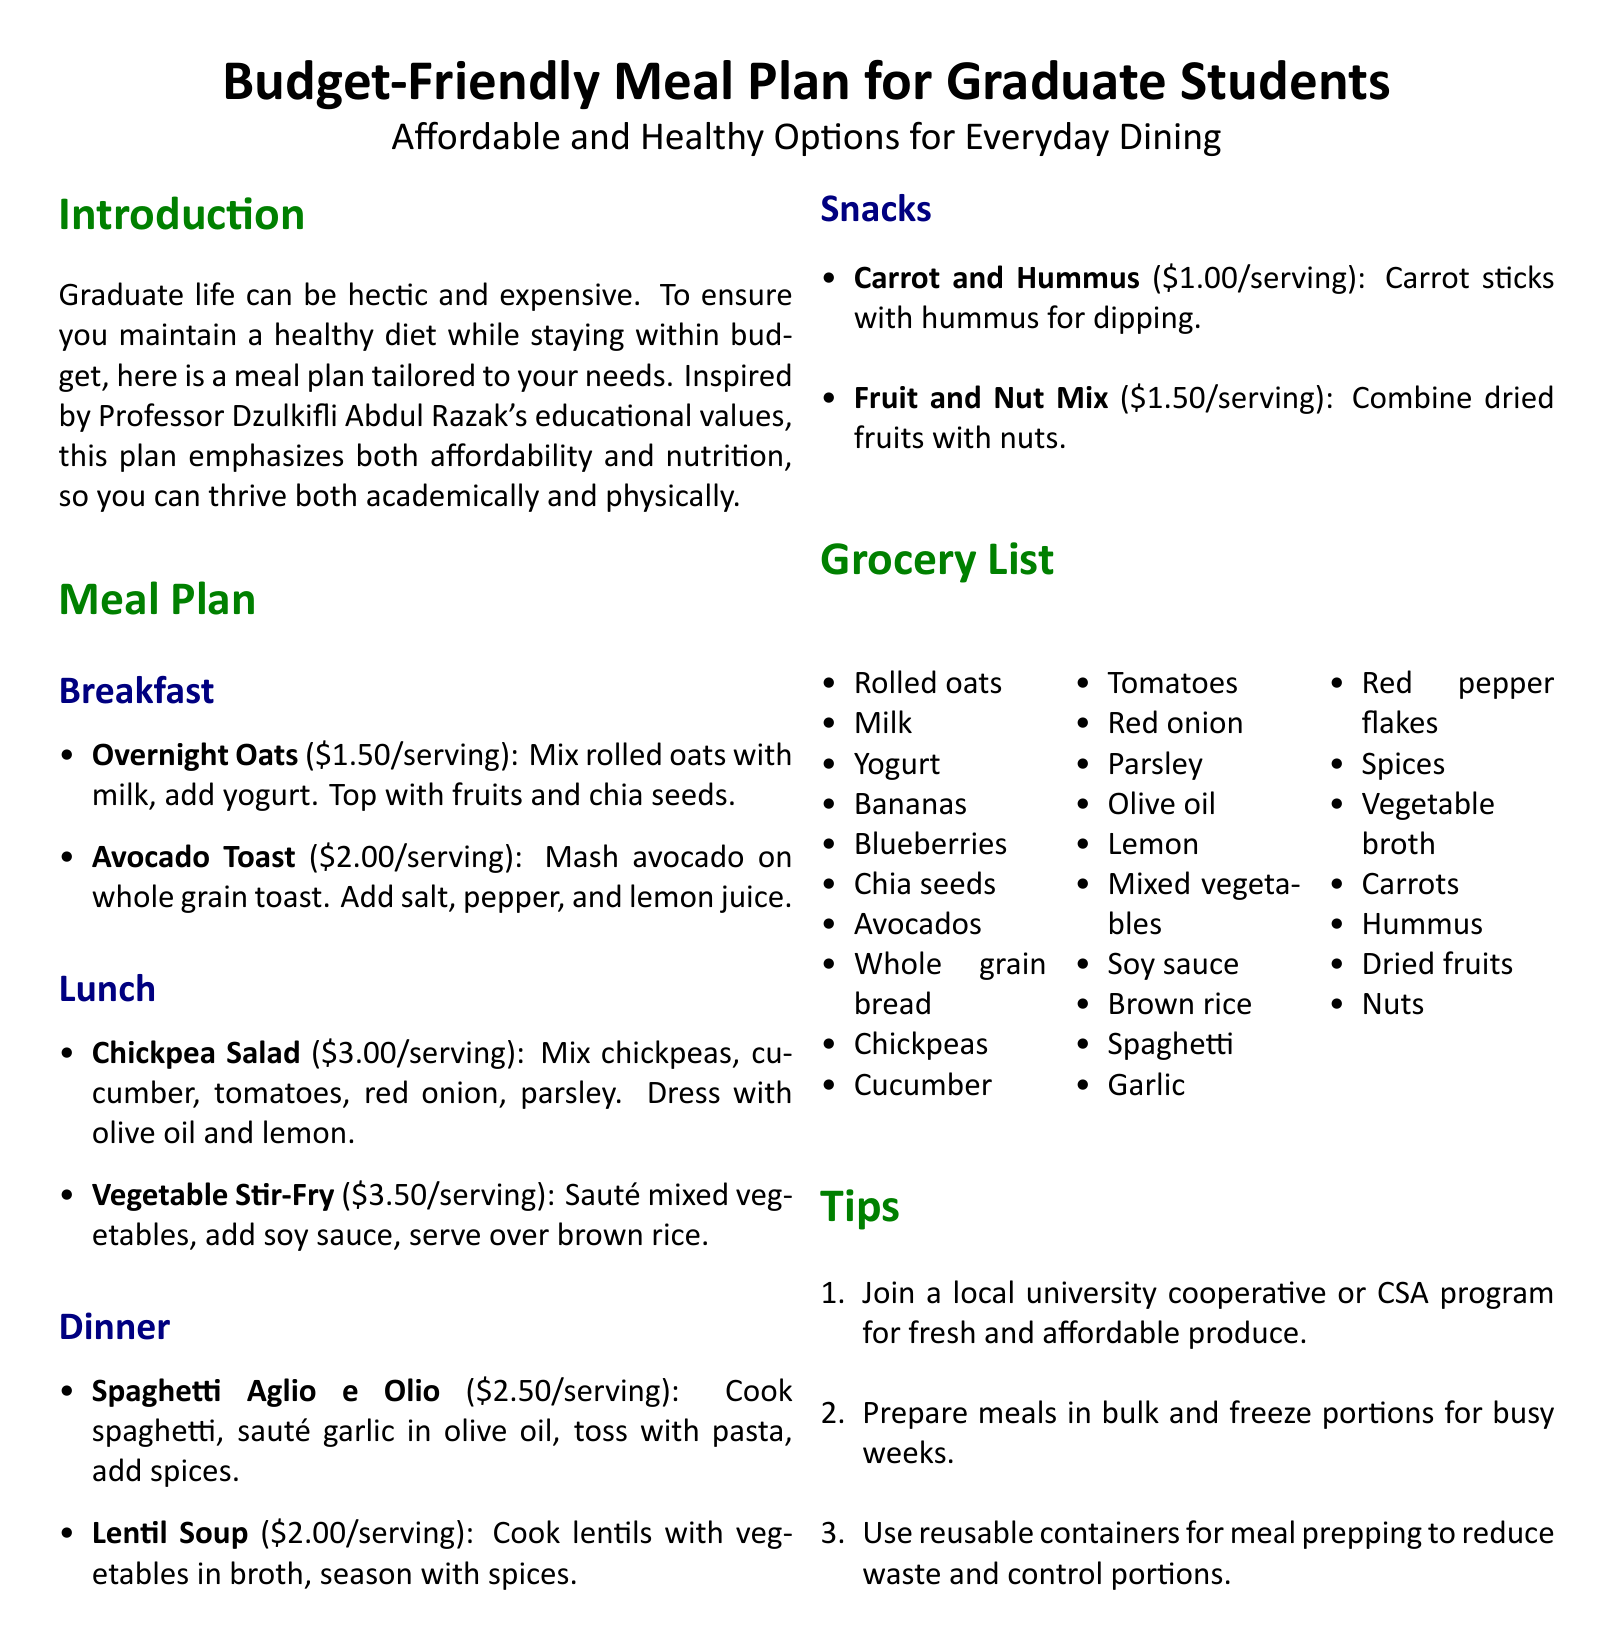What is the total cost of the Overnight Oats? The cost of the Overnight Oats is specified in the meal plan under Breakfast, which states it is $1.50 per serving.
Answer: $1.50 How many servings does the Vegetable Stir-Fry cost? The cost of the Vegetable Stir-Fry is listed in the Lunch section of the meal plan, where it is $3.50 per serving.
Answer: $3.50 What are the two ingredients in the Carrot and Hummus snack? The snack consists of carrot sticks and hummus, as mentioned in the Snacks section of the meal plan.
Answer: Carrots and hummus Which meal includes lentils? The Lentil Soup, listed under Dinner, includes lentils as its main ingredient.
Answer: Lentil Soup What is one tip for meal preparation? The tips section provides several suggestions; one example is preparing meals in bulk and freezing portions for busy weeks.
Answer: Prepare meals in bulk What ingredient is common between Chickpea Salad and the Vegetable Stir-Fry? Both meals include olive oil, which is noted in the grocery list and is an ingredient for both recipes.
Answer: Olive oil How many snacks are listed in the Meal Plan? The Snacks section contains two distinct snack options listed in the document.
Answer: Two What is the primary focus of the meal plan? The introduction states the meal plan focuses on being affordable and healthy to support graduate students.
Answer: Affordability and nutrition 